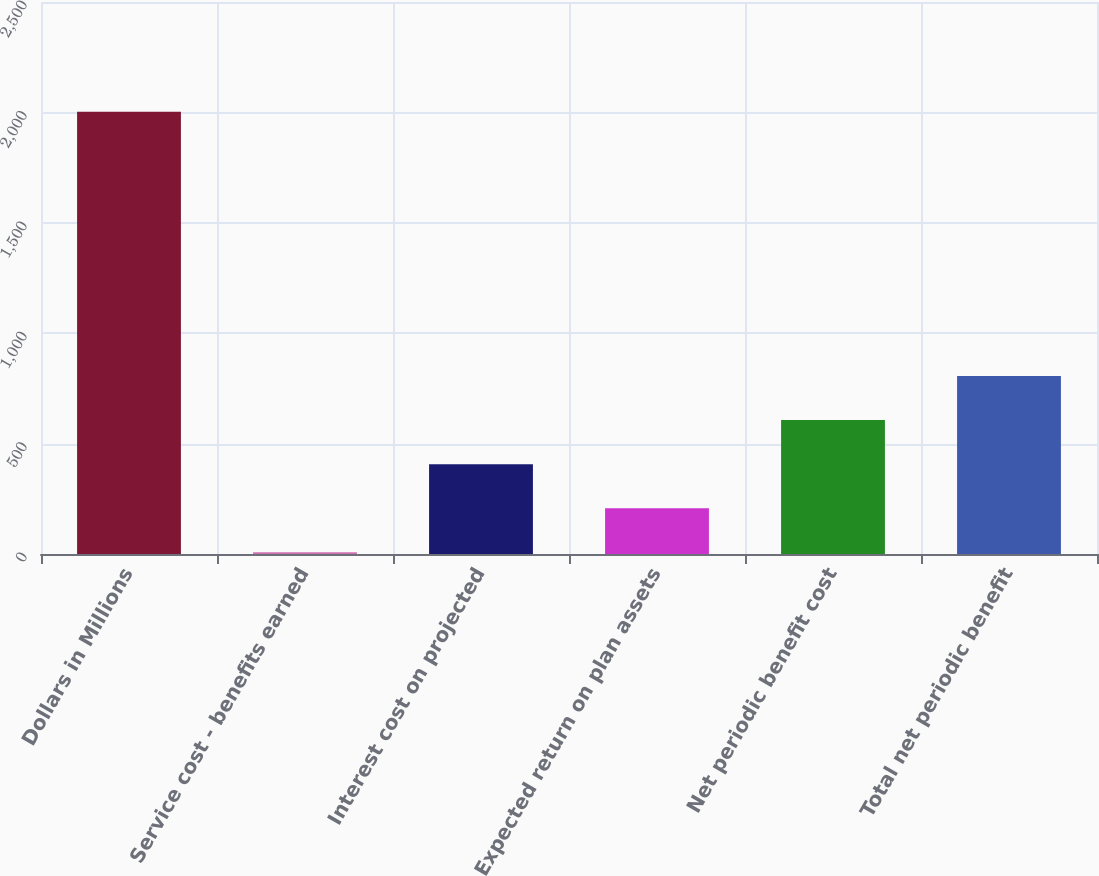<chart> <loc_0><loc_0><loc_500><loc_500><bar_chart><fcel>Dollars in Millions<fcel>Service cost - benefits earned<fcel>Interest cost on projected<fcel>Expected return on plan assets<fcel>Net periodic benefit cost<fcel>Total net periodic benefit<nl><fcel>2003<fcel>8<fcel>407<fcel>207.5<fcel>606.5<fcel>806<nl></chart> 